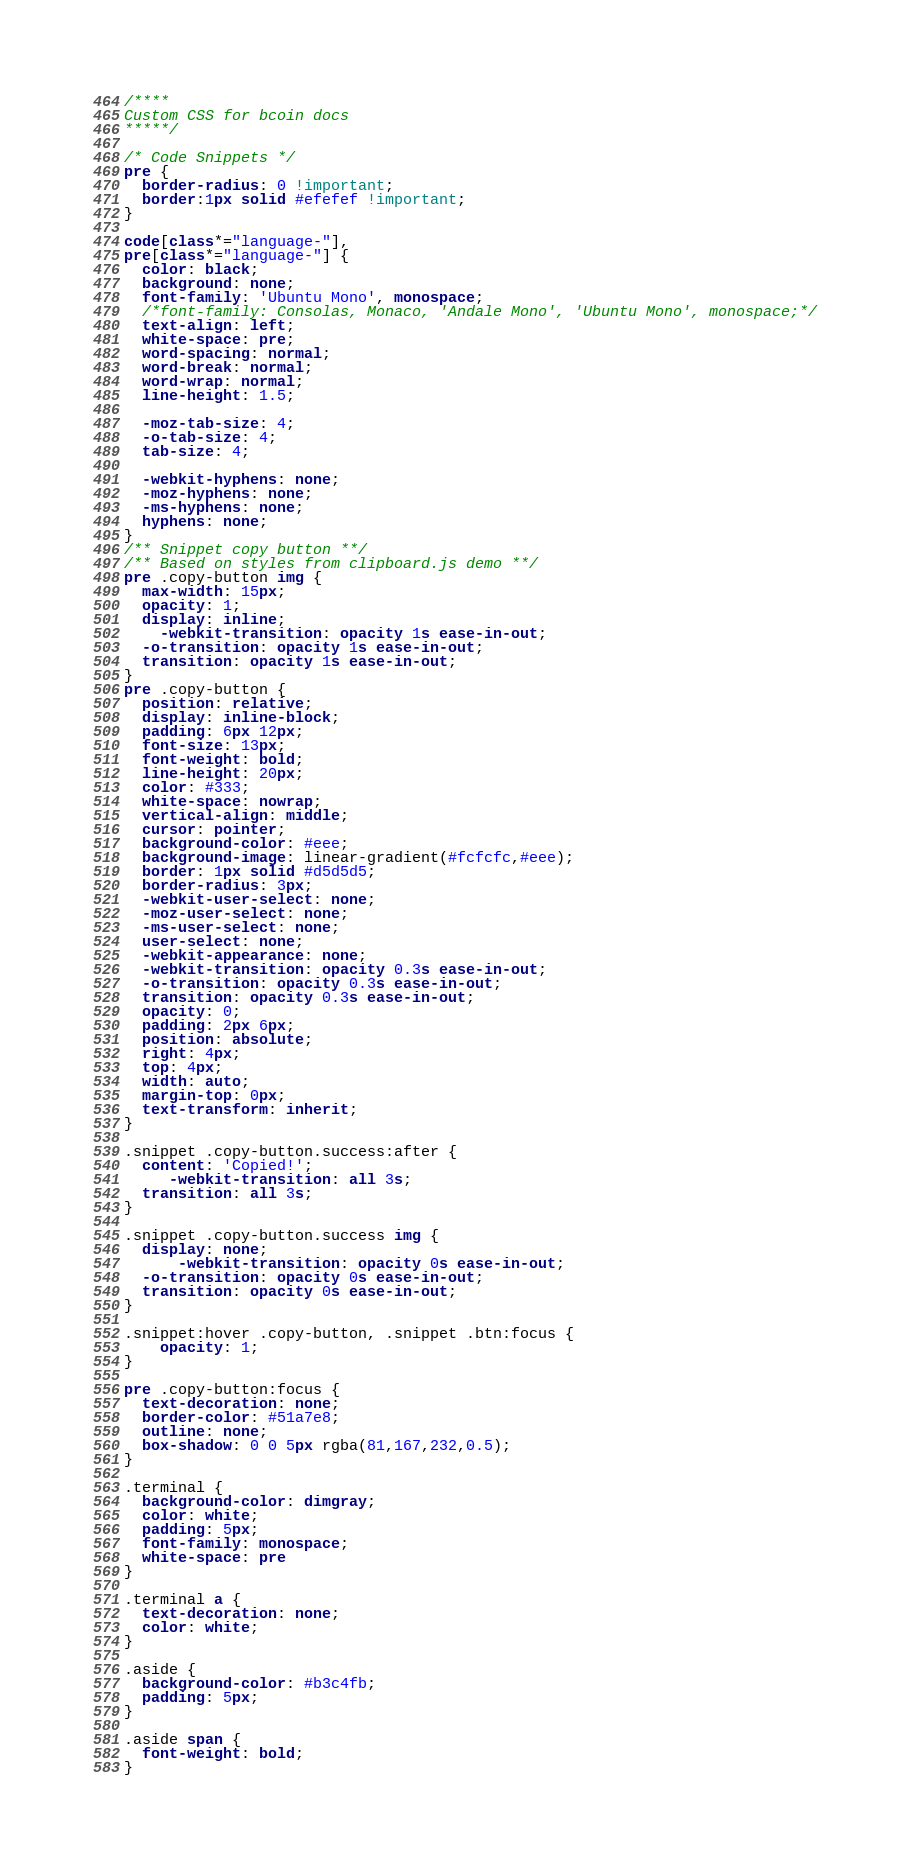Convert code to text. <code><loc_0><loc_0><loc_500><loc_500><_CSS_>/****
Custom CSS for bcoin docs
*****/

/* Code Snippets */
pre {
  border-radius: 0 !important;
  border:1px solid #efefef !important;
}

code[class*="language-"],
pre[class*="language-"] {
  color: black;
  background: none;
  font-family: 'Ubuntu Mono', monospace;
  /*font-family: Consolas, Monaco, 'Andale Mono', 'Ubuntu Mono', monospace;*/
  text-align: left;
  white-space: pre;
  word-spacing: normal;
  word-break: normal;
  word-wrap: normal;
  line-height: 1.5;

  -moz-tab-size: 4;
  -o-tab-size: 4;
  tab-size: 4;

  -webkit-hyphens: none;
  -moz-hyphens: none;
  -ms-hyphens: none;
  hyphens: none;
}
/** Snippet copy button **/
/** Based on styles from clipboard.js demo **/
pre .copy-button img {
  max-width: 15px;
  opacity: 1;
  display: inline;
    -webkit-transition: opacity 1s ease-in-out;
  -o-transition: opacity 1s ease-in-out;
  transition: opacity 1s ease-in-out;
}
pre .copy-button {
  position: relative;
  display: inline-block;
  padding: 6px 12px;
  font-size: 13px;
  font-weight: bold;
  line-height: 20px;
  color: #333;
  white-space: nowrap;
  vertical-align: middle;
  cursor: pointer;
  background-color: #eee;
  background-image: linear-gradient(#fcfcfc,#eee);
  border: 1px solid #d5d5d5;
  border-radius: 3px;
  -webkit-user-select: none;
  -moz-user-select: none;
  -ms-user-select: none;
  user-select: none;
  -webkit-appearance: none;
  -webkit-transition: opacity 0.3s ease-in-out;
  -o-transition: opacity 0.3s ease-in-out;
  transition: opacity 0.3s ease-in-out;
  opacity: 0;
  padding: 2px 6px;
  position: absolute;
  right: 4px;
  top: 4px;
  width: auto;
  margin-top: 0px;
  text-transform: inherit;
}

.snippet .copy-button.success:after {
  content: 'Copied!';
     -webkit-transition: all 3s;
  transition: all 3s;
}

.snippet .copy-button.success img {
  display: none;
      -webkit-transition: opacity 0s ease-in-out;
  -o-transition: opacity 0s ease-in-out;
  transition: opacity 0s ease-in-out;
}

.snippet:hover .copy-button, .snippet .btn:focus {
    opacity: 1;
}

pre .copy-button:focus {
  text-decoration: none;
  border-color: #51a7e8;
  outline: none;
  box-shadow: 0 0 5px rgba(81,167,232,0.5);
}

.terminal {
  background-color: dimgray;
  color: white;
  padding: 5px;
  font-family: monospace;
  white-space: pre
}

.terminal a {
  text-decoration: none;
  color: white;
}

.aside {
  background-color: #b3c4fb;
  padding: 5px;
}

.aside span {
  font-weight: bold;
}</code> 